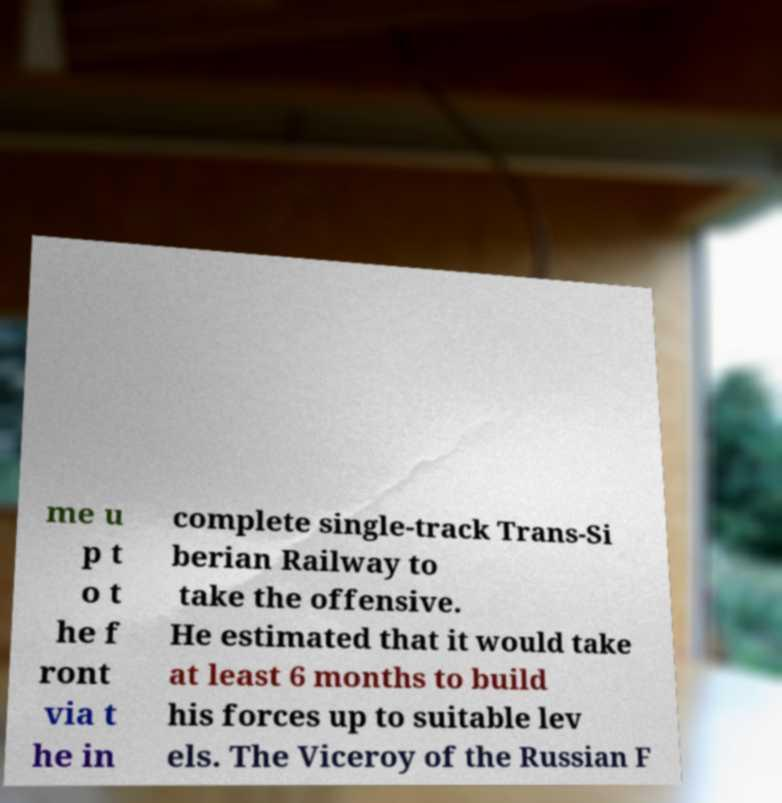Please identify and transcribe the text found in this image. me u p t o t he f ront via t he in complete single-track Trans-Si berian Railway to take the offensive. He estimated that it would take at least 6 months to build his forces up to suitable lev els. The Viceroy of the Russian F 